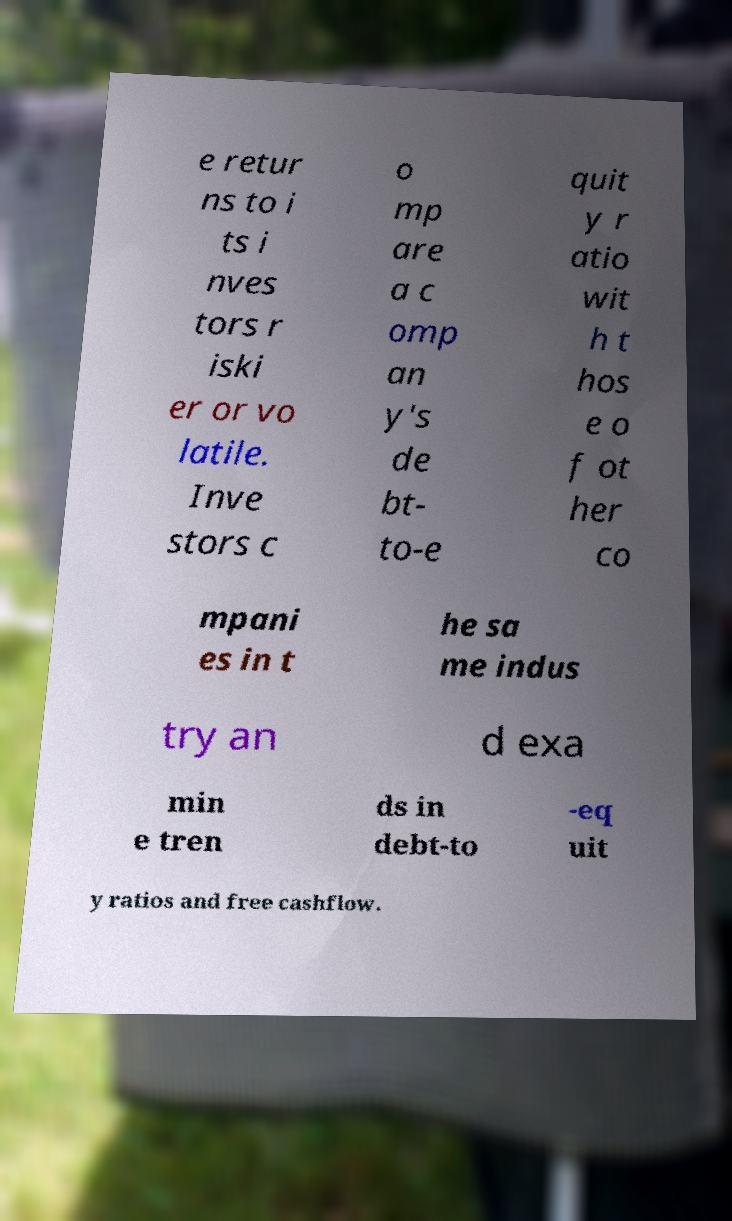Please identify and transcribe the text found in this image. e retur ns to i ts i nves tors r iski er or vo latile. Inve stors c o mp are a c omp an y's de bt- to-e quit y r atio wit h t hos e o f ot her co mpani es in t he sa me indus try an d exa min e tren ds in debt-to -eq uit y ratios and free cashflow. 